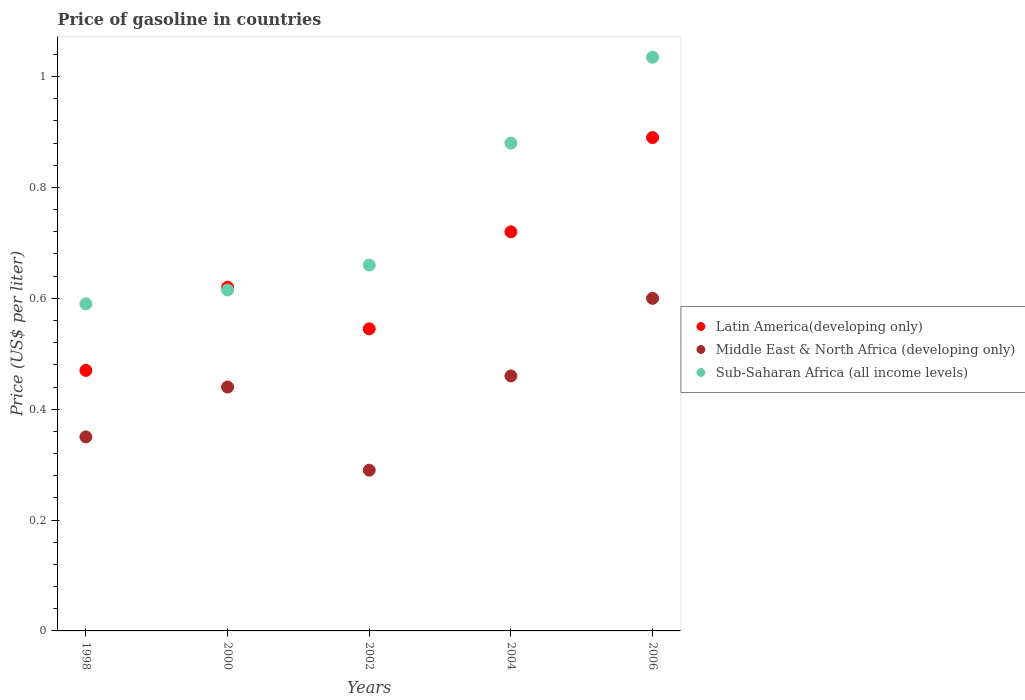How many different coloured dotlines are there?
Provide a short and direct response. 3. Is the number of dotlines equal to the number of legend labels?
Offer a terse response. Yes. What is the price of gasoline in Sub-Saharan Africa (all income levels) in 2002?
Offer a very short reply. 0.66. Across all years, what is the maximum price of gasoline in Latin America(developing only)?
Provide a succinct answer. 0.89. Across all years, what is the minimum price of gasoline in Latin America(developing only)?
Keep it short and to the point. 0.47. In which year was the price of gasoline in Sub-Saharan Africa (all income levels) maximum?
Your answer should be compact. 2006. What is the total price of gasoline in Middle East & North Africa (developing only) in the graph?
Give a very brief answer. 2.14. What is the difference between the price of gasoline in Sub-Saharan Africa (all income levels) in 2002 and that in 2006?
Your answer should be very brief. -0.37. What is the difference between the price of gasoline in Middle East & North Africa (developing only) in 1998 and the price of gasoline in Sub-Saharan Africa (all income levels) in 2002?
Your answer should be compact. -0.31. What is the average price of gasoline in Middle East & North Africa (developing only) per year?
Provide a succinct answer. 0.43. In the year 2002, what is the difference between the price of gasoline in Latin America(developing only) and price of gasoline in Middle East & North Africa (developing only)?
Your response must be concise. 0.26. What is the ratio of the price of gasoline in Middle East & North Africa (developing only) in 2000 to that in 2006?
Make the answer very short. 0.73. Is the price of gasoline in Middle East & North Africa (developing only) in 2000 less than that in 2004?
Provide a succinct answer. Yes. Is the difference between the price of gasoline in Latin America(developing only) in 2000 and 2004 greater than the difference between the price of gasoline in Middle East & North Africa (developing only) in 2000 and 2004?
Keep it short and to the point. No. What is the difference between the highest and the second highest price of gasoline in Middle East & North Africa (developing only)?
Offer a very short reply. 0.14. What is the difference between the highest and the lowest price of gasoline in Sub-Saharan Africa (all income levels)?
Your answer should be very brief. 0.44. In how many years, is the price of gasoline in Latin America(developing only) greater than the average price of gasoline in Latin America(developing only) taken over all years?
Your answer should be very brief. 2. Is the sum of the price of gasoline in Latin America(developing only) in 1998 and 2000 greater than the maximum price of gasoline in Middle East & North Africa (developing only) across all years?
Give a very brief answer. Yes. Is it the case that in every year, the sum of the price of gasoline in Middle East & North Africa (developing only) and price of gasoline in Sub-Saharan Africa (all income levels)  is greater than the price of gasoline in Latin America(developing only)?
Your answer should be very brief. Yes. Does the price of gasoline in Sub-Saharan Africa (all income levels) monotonically increase over the years?
Provide a short and direct response. Yes. Is the price of gasoline in Middle East & North Africa (developing only) strictly less than the price of gasoline in Sub-Saharan Africa (all income levels) over the years?
Provide a short and direct response. Yes. How many dotlines are there?
Keep it short and to the point. 3. What is the difference between two consecutive major ticks on the Y-axis?
Your answer should be very brief. 0.2. Are the values on the major ticks of Y-axis written in scientific E-notation?
Make the answer very short. No. Does the graph contain any zero values?
Give a very brief answer. No. What is the title of the graph?
Make the answer very short. Price of gasoline in countries. What is the label or title of the Y-axis?
Your answer should be compact. Price (US$ per liter). What is the Price (US$ per liter) in Latin America(developing only) in 1998?
Offer a terse response. 0.47. What is the Price (US$ per liter) in Sub-Saharan Africa (all income levels) in 1998?
Your response must be concise. 0.59. What is the Price (US$ per liter) in Latin America(developing only) in 2000?
Ensure brevity in your answer.  0.62. What is the Price (US$ per liter) in Middle East & North Africa (developing only) in 2000?
Offer a very short reply. 0.44. What is the Price (US$ per liter) in Sub-Saharan Africa (all income levels) in 2000?
Offer a terse response. 0.61. What is the Price (US$ per liter) of Latin America(developing only) in 2002?
Provide a succinct answer. 0.55. What is the Price (US$ per liter) in Middle East & North Africa (developing only) in 2002?
Ensure brevity in your answer.  0.29. What is the Price (US$ per liter) in Sub-Saharan Africa (all income levels) in 2002?
Give a very brief answer. 0.66. What is the Price (US$ per liter) in Latin America(developing only) in 2004?
Ensure brevity in your answer.  0.72. What is the Price (US$ per liter) in Middle East & North Africa (developing only) in 2004?
Your response must be concise. 0.46. What is the Price (US$ per liter) in Latin America(developing only) in 2006?
Your response must be concise. 0.89. What is the Price (US$ per liter) in Middle East & North Africa (developing only) in 2006?
Your response must be concise. 0.6. What is the Price (US$ per liter) in Sub-Saharan Africa (all income levels) in 2006?
Offer a terse response. 1.03. Across all years, what is the maximum Price (US$ per liter) of Latin America(developing only)?
Provide a succinct answer. 0.89. Across all years, what is the maximum Price (US$ per liter) of Sub-Saharan Africa (all income levels)?
Give a very brief answer. 1.03. Across all years, what is the minimum Price (US$ per liter) of Latin America(developing only)?
Make the answer very short. 0.47. Across all years, what is the minimum Price (US$ per liter) in Middle East & North Africa (developing only)?
Your answer should be compact. 0.29. Across all years, what is the minimum Price (US$ per liter) in Sub-Saharan Africa (all income levels)?
Offer a very short reply. 0.59. What is the total Price (US$ per liter) of Latin America(developing only) in the graph?
Make the answer very short. 3.25. What is the total Price (US$ per liter) of Middle East & North Africa (developing only) in the graph?
Provide a succinct answer. 2.14. What is the total Price (US$ per liter) of Sub-Saharan Africa (all income levels) in the graph?
Keep it short and to the point. 3.78. What is the difference between the Price (US$ per liter) in Latin America(developing only) in 1998 and that in 2000?
Provide a succinct answer. -0.15. What is the difference between the Price (US$ per liter) of Middle East & North Africa (developing only) in 1998 and that in 2000?
Keep it short and to the point. -0.09. What is the difference between the Price (US$ per liter) in Sub-Saharan Africa (all income levels) in 1998 and that in 2000?
Make the answer very short. -0.03. What is the difference between the Price (US$ per liter) in Latin America(developing only) in 1998 and that in 2002?
Your answer should be very brief. -0.07. What is the difference between the Price (US$ per liter) of Middle East & North Africa (developing only) in 1998 and that in 2002?
Provide a succinct answer. 0.06. What is the difference between the Price (US$ per liter) of Sub-Saharan Africa (all income levels) in 1998 and that in 2002?
Ensure brevity in your answer.  -0.07. What is the difference between the Price (US$ per liter) in Latin America(developing only) in 1998 and that in 2004?
Give a very brief answer. -0.25. What is the difference between the Price (US$ per liter) in Middle East & North Africa (developing only) in 1998 and that in 2004?
Your response must be concise. -0.11. What is the difference between the Price (US$ per liter) in Sub-Saharan Africa (all income levels) in 1998 and that in 2004?
Offer a very short reply. -0.29. What is the difference between the Price (US$ per liter) of Latin America(developing only) in 1998 and that in 2006?
Provide a short and direct response. -0.42. What is the difference between the Price (US$ per liter) of Sub-Saharan Africa (all income levels) in 1998 and that in 2006?
Provide a short and direct response. -0.45. What is the difference between the Price (US$ per liter) of Latin America(developing only) in 2000 and that in 2002?
Keep it short and to the point. 0.07. What is the difference between the Price (US$ per liter) in Sub-Saharan Africa (all income levels) in 2000 and that in 2002?
Ensure brevity in your answer.  -0.04. What is the difference between the Price (US$ per liter) of Latin America(developing only) in 2000 and that in 2004?
Make the answer very short. -0.1. What is the difference between the Price (US$ per liter) in Middle East & North Africa (developing only) in 2000 and that in 2004?
Ensure brevity in your answer.  -0.02. What is the difference between the Price (US$ per liter) in Sub-Saharan Africa (all income levels) in 2000 and that in 2004?
Provide a short and direct response. -0.27. What is the difference between the Price (US$ per liter) of Latin America(developing only) in 2000 and that in 2006?
Provide a short and direct response. -0.27. What is the difference between the Price (US$ per liter) in Middle East & North Africa (developing only) in 2000 and that in 2006?
Provide a succinct answer. -0.16. What is the difference between the Price (US$ per liter) in Sub-Saharan Africa (all income levels) in 2000 and that in 2006?
Your answer should be very brief. -0.42. What is the difference between the Price (US$ per liter) of Latin America(developing only) in 2002 and that in 2004?
Provide a short and direct response. -0.17. What is the difference between the Price (US$ per liter) of Middle East & North Africa (developing only) in 2002 and that in 2004?
Ensure brevity in your answer.  -0.17. What is the difference between the Price (US$ per liter) of Sub-Saharan Africa (all income levels) in 2002 and that in 2004?
Keep it short and to the point. -0.22. What is the difference between the Price (US$ per liter) in Latin America(developing only) in 2002 and that in 2006?
Provide a short and direct response. -0.34. What is the difference between the Price (US$ per liter) in Middle East & North Africa (developing only) in 2002 and that in 2006?
Provide a short and direct response. -0.31. What is the difference between the Price (US$ per liter) in Sub-Saharan Africa (all income levels) in 2002 and that in 2006?
Your response must be concise. -0.38. What is the difference between the Price (US$ per liter) of Latin America(developing only) in 2004 and that in 2006?
Keep it short and to the point. -0.17. What is the difference between the Price (US$ per liter) of Middle East & North Africa (developing only) in 2004 and that in 2006?
Make the answer very short. -0.14. What is the difference between the Price (US$ per liter) in Sub-Saharan Africa (all income levels) in 2004 and that in 2006?
Give a very brief answer. -0.15. What is the difference between the Price (US$ per liter) of Latin America(developing only) in 1998 and the Price (US$ per liter) of Middle East & North Africa (developing only) in 2000?
Make the answer very short. 0.03. What is the difference between the Price (US$ per liter) in Latin America(developing only) in 1998 and the Price (US$ per liter) in Sub-Saharan Africa (all income levels) in 2000?
Offer a very short reply. -0.14. What is the difference between the Price (US$ per liter) in Middle East & North Africa (developing only) in 1998 and the Price (US$ per liter) in Sub-Saharan Africa (all income levels) in 2000?
Your answer should be very brief. -0.27. What is the difference between the Price (US$ per liter) of Latin America(developing only) in 1998 and the Price (US$ per liter) of Middle East & North Africa (developing only) in 2002?
Provide a short and direct response. 0.18. What is the difference between the Price (US$ per liter) in Latin America(developing only) in 1998 and the Price (US$ per liter) in Sub-Saharan Africa (all income levels) in 2002?
Make the answer very short. -0.19. What is the difference between the Price (US$ per liter) in Middle East & North Africa (developing only) in 1998 and the Price (US$ per liter) in Sub-Saharan Africa (all income levels) in 2002?
Provide a short and direct response. -0.31. What is the difference between the Price (US$ per liter) in Latin America(developing only) in 1998 and the Price (US$ per liter) in Sub-Saharan Africa (all income levels) in 2004?
Your answer should be compact. -0.41. What is the difference between the Price (US$ per liter) in Middle East & North Africa (developing only) in 1998 and the Price (US$ per liter) in Sub-Saharan Africa (all income levels) in 2004?
Ensure brevity in your answer.  -0.53. What is the difference between the Price (US$ per liter) of Latin America(developing only) in 1998 and the Price (US$ per liter) of Middle East & North Africa (developing only) in 2006?
Ensure brevity in your answer.  -0.13. What is the difference between the Price (US$ per liter) of Latin America(developing only) in 1998 and the Price (US$ per liter) of Sub-Saharan Africa (all income levels) in 2006?
Your answer should be very brief. -0.56. What is the difference between the Price (US$ per liter) of Middle East & North Africa (developing only) in 1998 and the Price (US$ per liter) of Sub-Saharan Africa (all income levels) in 2006?
Provide a succinct answer. -0.69. What is the difference between the Price (US$ per liter) of Latin America(developing only) in 2000 and the Price (US$ per liter) of Middle East & North Africa (developing only) in 2002?
Your response must be concise. 0.33. What is the difference between the Price (US$ per liter) in Latin America(developing only) in 2000 and the Price (US$ per liter) in Sub-Saharan Africa (all income levels) in 2002?
Give a very brief answer. -0.04. What is the difference between the Price (US$ per liter) in Middle East & North Africa (developing only) in 2000 and the Price (US$ per liter) in Sub-Saharan Africa (all income levels) in 2002?
Offer a very short reply. -0.22. What is the difference between the Price (US$ per liter) in Latin America(developing only) in 2000 and the Price (US$ per liter) in Middle East & North Africa (developing only) in 2004?
Ensure brevity in your answer.  0.16. What is the difference between the Price (US$ per liter) of Latin America(developing only) in 2000 and the Price (US$ per liter) of Sub-Saharan Africa (all income levels) in 2004?
Your response must be concise. -0.26. What is the difference between the Price (US$ per liter) of Middle East & North Africa (developing only) in 2000 and the Price (US$ per liter) of Sub-Saharan Africa (all income levels) in 2004?
Ensure brevity in your answer.  -0.44. What is the difference between the Price (US$ per liter) in Latin America(developing only) in 2000 and the Price (US$ per liter) in Sub-Saharan Africa (all income levels) in 2006?
Keep it short and to the point. -0.41. What is the difference between the Price (US$ per liter) in Middle East & North Africa (developing only) in 2000 and the Price (US$ per liter) in Sub-Saharan Africa (all income levels) in 2006?
Make the answer very short. -0.59. What is the difference between the Price (US$ per liter) of Latin America(developing only) in 2002 and the Price (US$ per liter) of Middle East & North Africa (developing only) in 2004?
Your response must be concise. 0.09. What is the difference between the Price (US$ per liter) of Latin America(developing only) in 2002 and the Price (US$ per liter) of Sub-Saharan Africa (all income levels) in 2004?
Your answer should be compact. -0.34. What is the difference between the Price (US$ per liter) of Middle East & North Africa (developing only) in 2002 and the Price (US$ per liter) of Sub-Saharan Africa (all income levels) in 2004?
Keep it short and to the point. -0.59. What is the difference between the Price (US$ per liter) of Latin America(developing only) in 2002 and the Price (US$ per liter) of Middle East & North Africa (developing only) in 2006?
Offer a terse response. -0.06. What is the difference between the Price (US$ per liter) of Latin America(developing only) in 2002 and the Price (US$ per liter) of Sub-Saharan Africa (all income levels) in 2006?
Ensure brevity in your answer.  -0.49. What is the difference between the Price (US$ per liter) in Middle East & North Africa (developing only) in 2002 and the Price (US$ per liter) in Sub-Saharan Africa (all income levels) in 2006?
Offer a very short reply. -0.74. What is the difference between the Price (US$ per liter) in Latin America(developing only) in 2004 and the Price (US$ per liter) in Middle East & North Africa (developing only) in 2006?
Your answer should be very brief. 0.12. What is the difference between the Price (US$ per liter) of Latin America(developing only) in 2004 and the Price (US$ per liter) of Sub-Saharan Africa (all income levels) in 2006?
Give a very brief answer. -0.32. What is the difference between the Price (US$ per liter) in Middle East & North Africa (developing only) in 2004 and the Price (US$ per liter) in Sub-Saharan Africa (all income levels) in 2006?
Make the answer very short. -0.57. What is the average Price (US$ per liter) in Latin America(developing only) per year?
Your answer should be compact. 0.65. What is the average Price (US$ per liter) in Middle East & North Africa (developing only) per year?
Offer a terse response. 0.43. What is the average Price (US$ per liter) of Sub-Saharan Africa (all income levels) per year?
Offer a terse response. 0.76. In the year 1998, what is the difference between the Price (US$ per liter) of Latin America(developing only) and Price (US$ per liter) of Middle East & North Africa (developing only)?
Make the answer very short. 0.12. In the year 1998, what is the difference between the Price (US$ per liter) in Latin America(developing only) and Price (US$ per liter) in Sub-Saharan Africa (all income levels)?
Offer a terse response. -0.12. In the year 1998, what is the difference between the Price (US$ per liter) in Middle East & North Africa (developing only) and Price (US$ per liter) in Sub-Saharan Africa (all income levels)?
Keep it short and to the point. -0.24. In the year 2000, what is the difference between the Price (US$ per liter) of Latin America(developing only) and Price (US$ per liter) of Middle East & North Africa (developing only)?
Provide a short and direct response. 0.18. In the year 2000, what is the difference between the Price (US$ per liter) of Latin America(developing only) and Price (US$ per liter) of Sub-Saharan Africa (all income levels)?
Your answer should be compact. 0.01. In the year 2000, what is the difference between the Price (US$ per liter) of Middle East & North Africa (developing only) and Price (US$ per liter) of Sub-Saharan Africa (all income levels)?
Offer a terse response. -0.17. In the year 2002, what is the difference between the Price (US$ per liter) of Latin America(developing only) and Price (US$ per liter) of Middle East & North Africa (developing only)?
Offer a terse response. 0.26. In the year 2002, what is the difference between the Price (US$ per liter) of Latin America(developing only) and Price (US$ per liter) of Sub-Saharan Africa (all income levels)?
Offer a terse response. -0.12. In the year 2002, what is the difference between the Price (US$ per liter) in Middle East & North Africa (developing only) and Price (US$ per liter) in Sub-Saharan Africa (all income levels)?
Provide a short and direct response. -0.37. In the year 2004, what is the difference between the Price (US$ per liter) of Latin America(developing only) and Price (US$ per liter) of Middle East & North Africa (developing only)?
Your response must be concise. 0.26. In the year 2004, what is the difference between the Price (US$ per liter) in Latin America(developing only) and Price (US$ per liter) in Sub-Saharan Africa (all income levels)?
Keep it short and to the point. -0.16. In the year 2004, what is the difference between the Price (US$ per liter) in Middle East & North Africa (developing only) and Price (US$ per liter) in Sub-Saharan Africa (all income levels)?
Make the answer very short. -0.42. In the year 2006, what is the difference between the Price (US$ per liter) in Latin America(developing only) and Price (US$ per liter) in Middle East & North Africa (developing only)?
Provide a short and direct response. 0.29. In the year 2006, what is the difference between the Price (US$ per liter) of Latin America(developing only) and Price (US$ per liter) of Sub-Saharan Africa (all income levels)?
Provide a succinct answer. -0.14. In the year 2006, what is the difference between the Price (US$ per liter) of Middle East & North Africa (developing only) and Price (US$ per liter) of Sub-Saharan Africa (all income levels)?
Provide a short and direct response. -0.43. What is the ratio of the Price (US$ per liter) of Latin America(developing only) in 1998 to that in 2000?
Keep it short and to the point. 0.76. What is the ratio of the Price (US$ per liter) in Middle East & North Africa (developing only) in 1998 to that in 2000?
Your answer should be compact. 0.8. What is the ratio of the Price (US$ per liter) of Sub-Saharan Africa (all income levels) in 1998 to that in 2000?
Your answer should be compact. 0.96. What is the ratio of the Price (US$ per liter) of Latin America(developing only) in 1998 to that in 2002?
Provide a short and direct response. 0.86. What is the ratio of the Price (US$ per liter) in Middle East & North Africa (developing only) in 1998 to that in 2002?
Your answer should be very brief. 1.21. What is the ratio of the Price (US$ per liter) in Sub-Saharan Africa (all income levels) in 1998 to that in 2002?
Ensure brevity in your answer.  0.89. What is the ratio of the Price (US$ per liter) of Latin America(developing only) in 1998 to that in 2004?
Ensure brevity in your answer.  0.65. What is the ratio of the Price (US$ per liter) of Middle East & North Africa (developing only) in 1998 to that in 2004?
Provide a short and direct response. 0.76. What is the ratio of the Price (US$ per liter) in Sub-Saharan Africa (all income levels) in 1998 to that in 2004?
Keep it short and to the point. 0.67. What is the ratio of the Price (US$ per liter) in Latin America(developing only) in 1998 to that in 2006?
Give a very brief answer. 0.53. What is the ratio of the Price (US$ per liter) of Middle East & North Africa (developing only) in 1998 to that in 2006?
Give a very brief answer. 0.58. What is the ratio of the Price (US$ per liter) in Sub-Saharan Africa (all income levels) in 1998 to that in 2006?
Ensure brevity in your answer.  0.57. What is the ratio of the Price (US$ per liter) of Latin America(developing only) in 2000 to that in 2002?
Your answer should be very brief. 1.14. What is the ratio of the Price (US$ per liter) in Middle East & North Africa (developing only) in 2000 to that in 2002?
Give a very brief answer. 1.52. What is the ratio of the Price (US$ per liter) in Sub-Saharan Africa (all income levels) in 2000 to that in 2002?
Provide a short and direct response. 0.93. What is the ratio of the Price (US$ per liter) in Latin America(developing only) in 2000 to that in 2004?
Provide a succinct answer. 0.86. What is the ratio of the Price (US$ per liter) of Middle East & North Africa (developing only) in 2000 to that in 2004?
Give a very brief answer. 0.96. What is the ratio of the Price (US$ per liter) in Sub-Saharan Africa (all income levels) in 2000 to that in 2004?
Give a very brief answer. 0.7. What is the ratio of the Price (US$ per liter) of Latin America(developing only) in 2000 to that in 2006?
Make the answer very short. 0.7. What is the ratio of the Price (US$ per liter) of Middle East & North Africa (developing only) in 2000 to that in 2006?
Ensure brevity in your answer.  0.73. What is the ratio of the Price (US$ per liter) of Sub-Saharan Africa (all income levels) in 2000 to that in 2006?
Offer a very short reply. 0.59. What is the ratio of the Price (US$ per liter) in Latin America(developing only) in 2002 to that in 2004?
Your answer should be very brief. 0.76. What is the ratio of the Price (US$ per liter) in Middle East & North Africa (developing only) in 2002 to that in 2004?
Make the answer very short. 0.63. What is the ratio of the Price (US$ per liter) of Sub-Saharan Africa (all income levels) in 2002 to that in 2004?
Ensure brevity in your answer.  0.75. What is the ratio of the Price (US$ per liter) of Latin America(developing only) in 2002 to that in 2006?
Keep it short and to the point. 0.61. What is the ratio of the Price (US$ per liter) in Middle East & North Africa (developing only) in 2002 to that in 2006?
Your answer should be compact. 0.48. What is the ratio of the Price (US$ per liter) of Sub-Saharan Africa (all income levels) in 2002 to that in 2006?
Provide a short and direct response. 0.64. What is the ratio of the Price (US$ per liter) in Latin America(developing only) in 2004 to that in 2006?
Make the answer very short. 0.81. What is the ratio of the Price (US$ per liter) in Middle East & North Africa (developing only) in 2004 to that in 2006?
Give a very brief answer. 0.77. What is the ratio of the Price (US$ per liter) of Sub-Saharan Africa (all income levels) in 2004 to that in 2006?
Offer a terse response. 0.85. What is the difference between the highest and the second highest Price (US$ per liter) of Latin America(developing only)?
Give a very brief answer. 0.17. What is the difference between the highest and the second highest Price (US$ per liter) of Middle East & North Africa (developing only)?
Offer a terse response. 0.14. What is the difference between the highest and the second highest Price (US$ per liter) in Sub-Saharan Africa (all income levels)?
Make the answer very short. 0.15. What is the difference between the highest and the lowest Price (US$ per liter) in Latin America(developing only)?
Offer a terse response. 0.42. What is the difference between the highest and the lowest Price (US$ per liter) of Middle East & North Africa (developing only)?
Your answer should be very brief. 0.31. What is the difference between the highest and the lowest Price (US$ per liter) in Sub-Saharan Africa (all income levels)?
Your answer should be very brief. 0.45. 